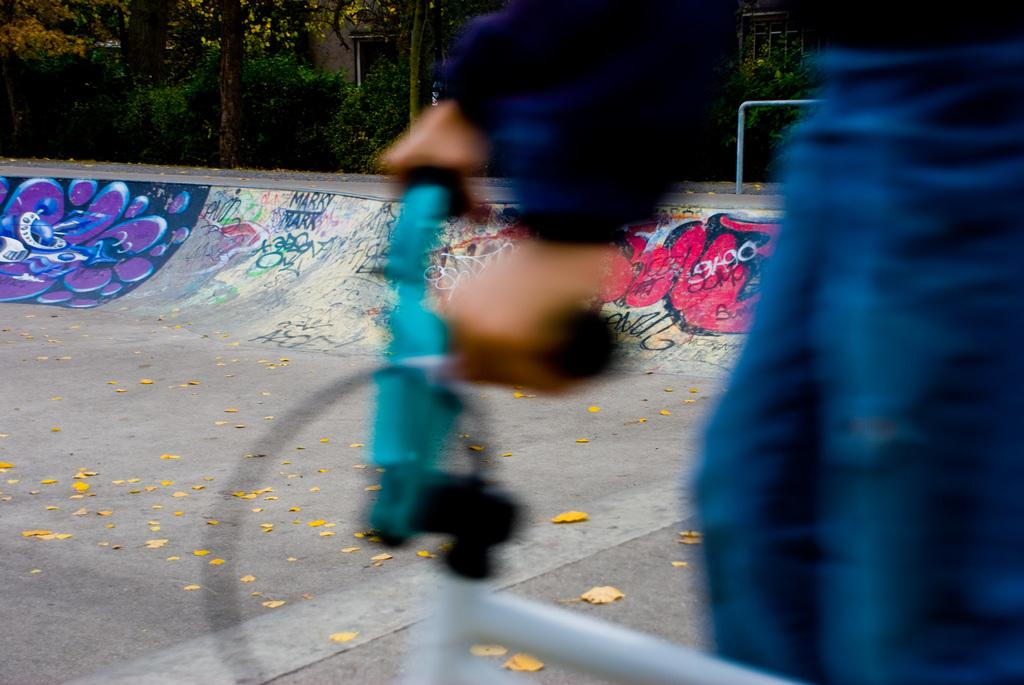What is the main activity being performed by the person in the image? There is a person cycling in the image. What is the person wearing while cycling? The person is wearing a blue dress. What type of surface can be seen at the bottom of the image? There is a road at the bottom of the image. What can be seen in the distance behind the person cycling? There are trees in the background of the image. What type of relation does the person cycling have with the hole in the image? There is no hole present in the image, so it is not possible to determine any relation between the person cycling and a hole. 